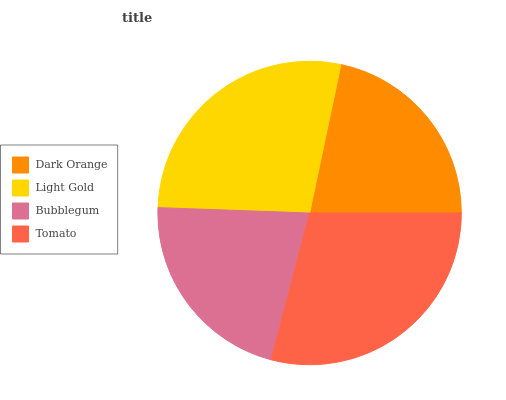Is Bubblegum the minimum?
Answer yes or no. Yes. Is Tomato the maximum?
Answer yes or no. Yes. Is Light Gold the minimum?
Answer yes or no. No. Is Light Gold the maximum?
Answer yes or no. No. Is Light Gold greater than Dark Orange?
Answer yes or no. Yes. Is Dark Orange less than Light Gold?
Answer yes or no. Yes. Is Dark Orange greater than Light Gold?
Answer yes or no. No. Is Light Gold less than Dark Orange?
Answer yes or no. No. Is Light Gold the high median?
Answer yes or no. Yes. Is Dark Orange the low median?
Answer yes or no. Yes. Is Bubblegum the high median?
Answer yes or no. No. Is Bubblegum the low median?
Answer yes or no. No. 